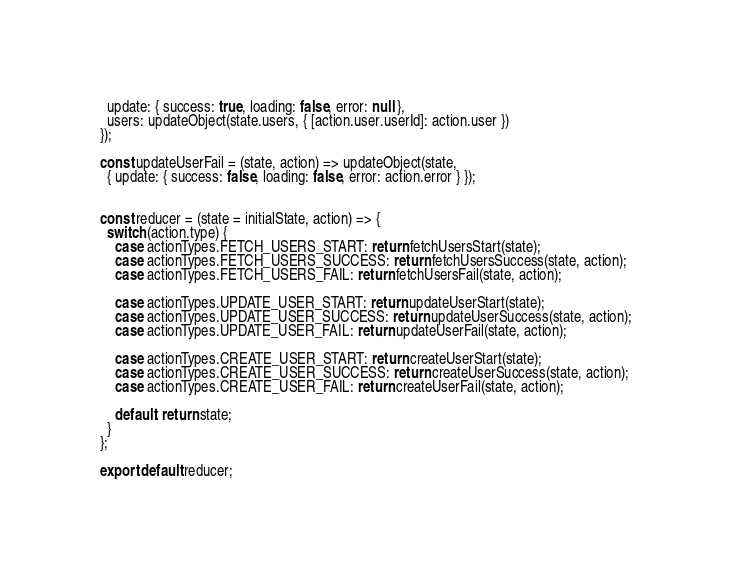Convert code to text. <code><loc_0><loc_0><loc_500><loc_500><_JavaScript_>  update: { success: true, loading: false, error: null },
  users: updateObject(state.users, { [action.user.userId]: action.user })
});

const updateUserFail = (state, action) => updateObject(state,
  { update: { success: false, loading: false, error: action.error } });


const reducer = (state = initialState, action) => {
  switch (action.type) {
    case actionTypes.FETCH_USERS_START: return fetchUsersStart(state);
    case actionTypes.FETCH_USERS_SUCCESS: return fetchUsersSuccess(state, action);
    case actionTypes.FETCH_USERS_FAIL: return fetchUsersFail(state, action);

    case actionTypes.UPDATE_USER_START: return updateUserStart(state);
    case actionTypes.UPDATE_USER_SUCCESS: return updateUserSuccess(state, action);
    case actionTypes.UPDATE_USER_FAIL: return updateUserFail(state, action);

    case actionTypes.CREATE_USER_START: return createUserStart(state);
    case actionTypes.CREATE_USER_SUCCESS: return createUserSuccess(state, action);
    case actionTypes.CREATE_USER_FAIL: return createUserFail(state, action);

    default: return state;
  }
};

export default reducer;</code> 